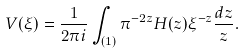Convert formula to latex. <formula><loc_0><loc_0><loc_500><loc_500>V ( \xi ) = \frac { 1 } { 2 \pi i } \int _ { ( 1 ) } \pi ^ { - 2 z } H ( z ) \xi ^ { - z } \frac { d z } { z } .</formula> 